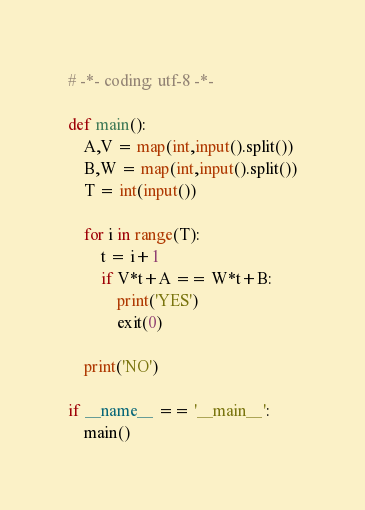<code> <loc_0><loc_0><loc_500><loc_500><_Python_># -*- coding: utf-8 -*-

def main():
    A,V = map(int,input().split())
    B,W = map(int,input().split())
    T = int(input())

    for i in range(T):
        t = i+1
        if V*t+A == W*t+B:
            print('YES')
            exit(0)

    print('NO')

if __name__ == '__main__':
    main()
</code> 